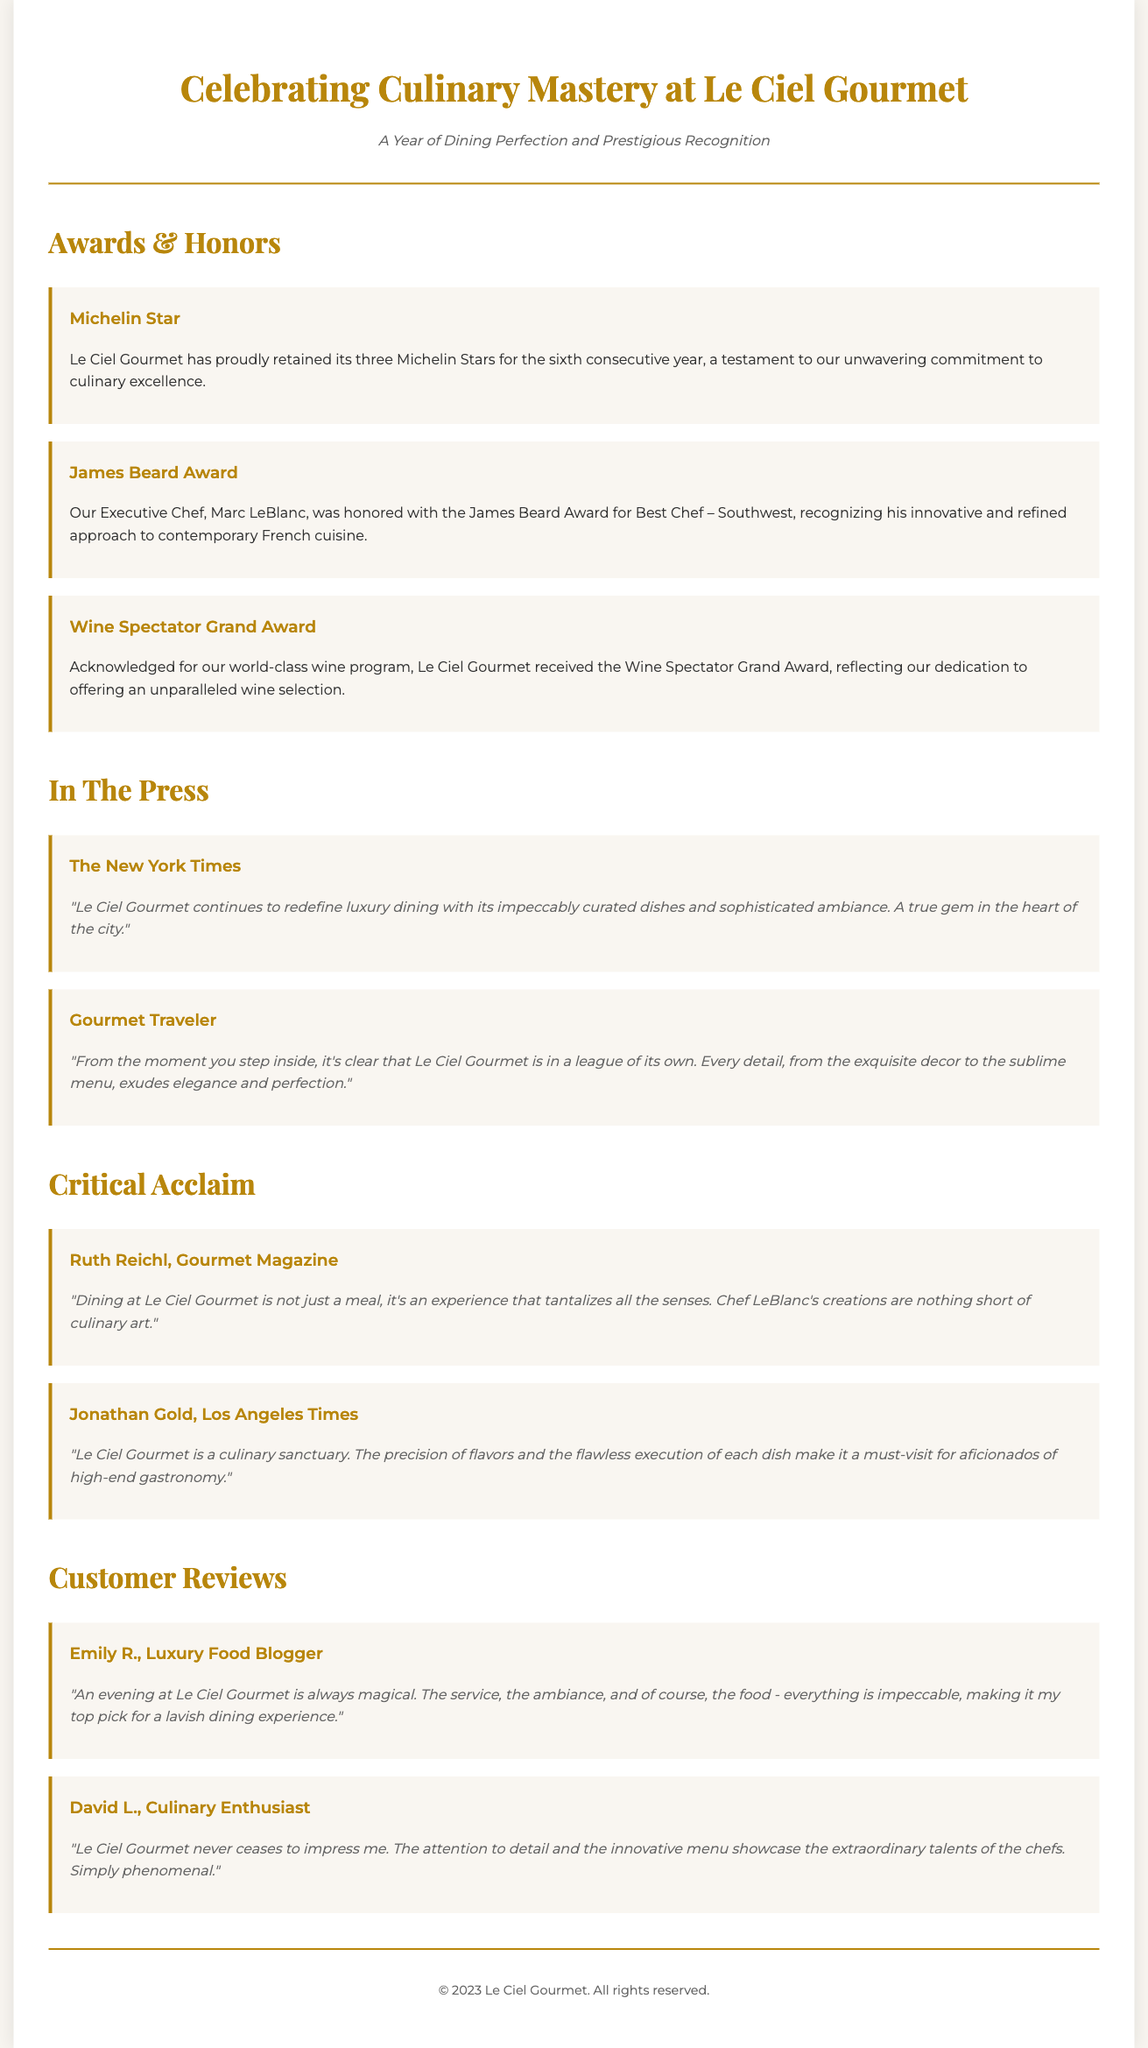What award has Le Ciel Gourmet retained for six consecutive years? The Michelin Star is retained for six consecutive years, showcasing culinary excellence.
Answer: Michelin Star Who is the recipient of the James Beard Award? The Executive Chef, Marc LeBlanc, received the James Beard Award for Best Chef – Southwest, highlighting his innovative approach.
Answer: Marc LeBlanc What level of award did Le Ciel Gourmet receive from Wine Spectator? The restaurant received the Wine Spectator Grand Award for its world-class wine program.
Answer: Grand Award Which publication described Le Ciel Gourmet as "a true gem in the heart of the city"? The New York Times praised the restaurant, indicating its high esteem in the culinary world.
Answer: The New York Times What does Ruth Reichl say about dining at Le Ciel Gourmet? She mentions that it's not just a meal, but an experience that tantalizes all the senses, emphasizing the unique dining experience.
Answer: An experience that tantalizes all the senses How many Michelin Stars has Le Ciel Gourmet achieved? The restaurant has achieved three Michelin Stars, signifying its top-tier status in the culinary scene.
Answer: three What was emphasized about Chef LeBlanc's creations in Gourmet Magazine? They are described as nothing short of culinary art, underscoring the high quality of his dishes.
Answer: Culinary art 